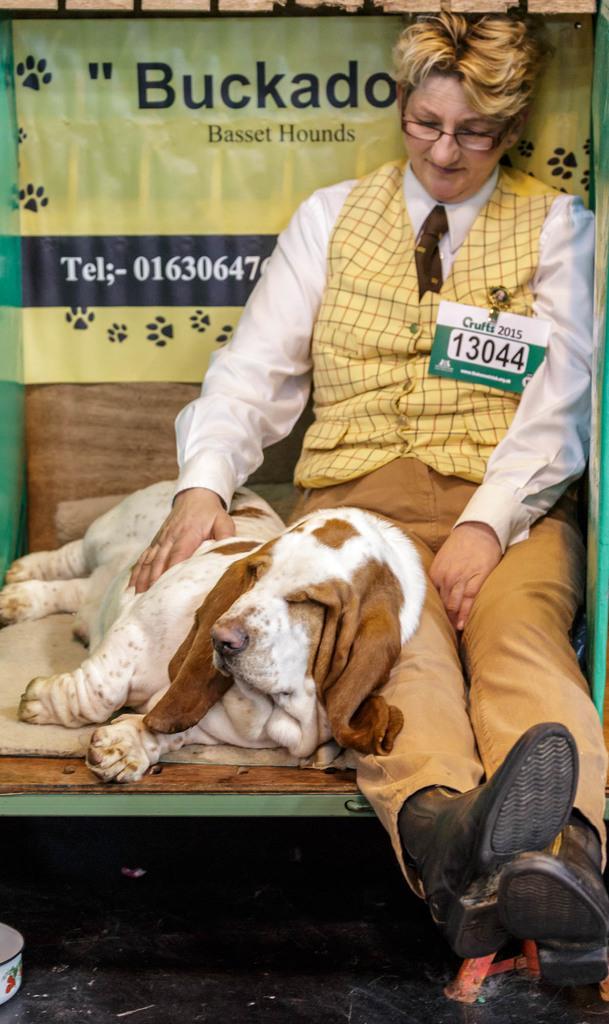How would you summarize this image in a sentence or two? In this image we can see a dog lying beside a person sitting. In the background there is an advertisement. 